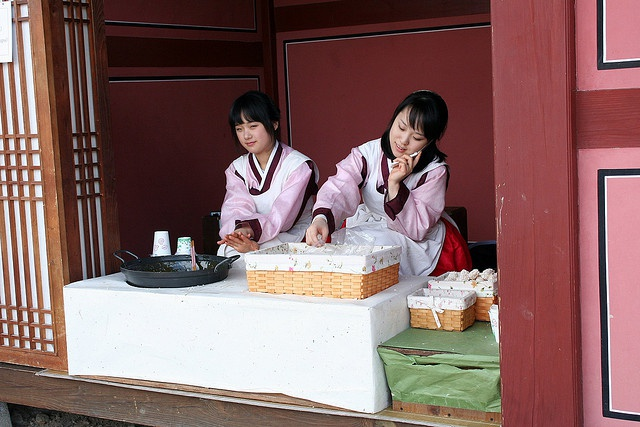Describe the objects in this image and their specific colors. I can see people in lightblue, black, darkgray, lavender, and maroon tones, people in lightblue, lavender, black, pink, and darkgray tones, bowl in lightblue, black, gray, and darkblue tones, chair in maroon, black, and lightblue tones, and cup in lightblue, lavender, black, and darkgray tones in this image. 